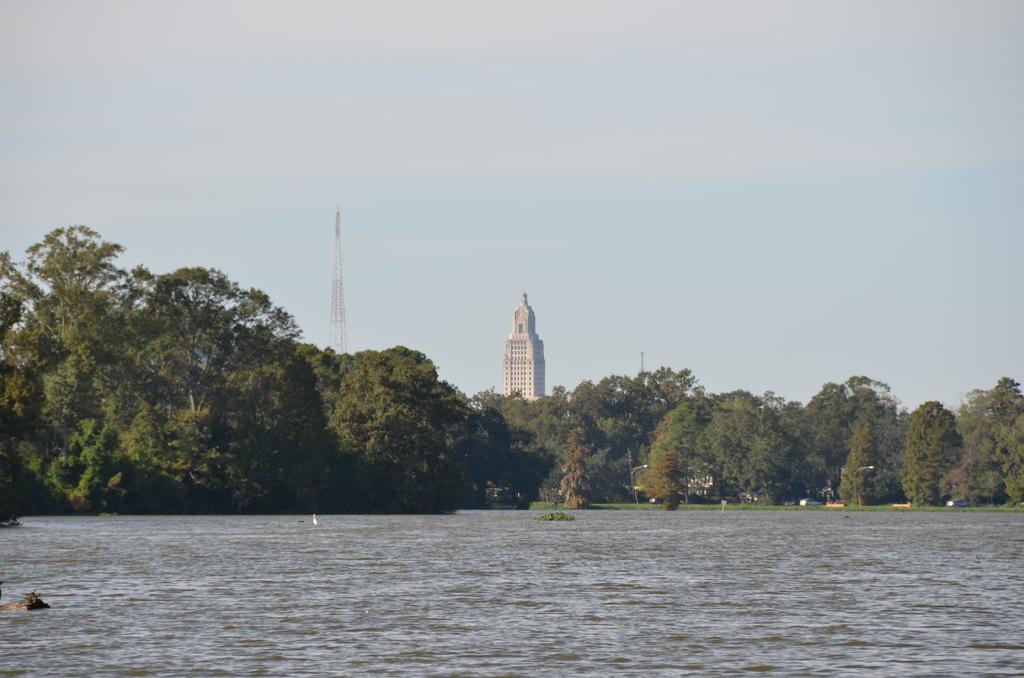How would you summarize this image in a sentence or two? In this image we can see the lake and there are some trees. In the background, we can see a building and there is a tower and at the top we can see the sky. 